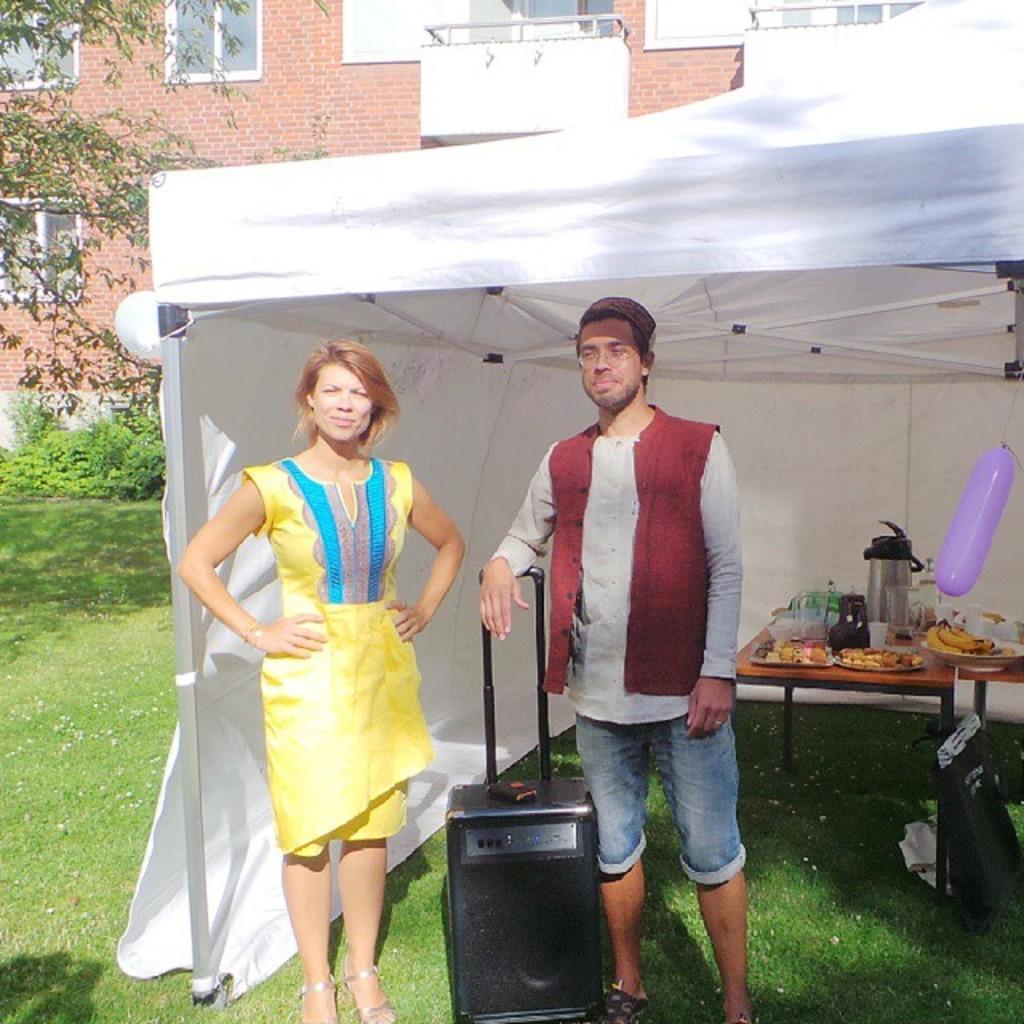Describe this image in one or two sentences. A couple are standing under a tent with a portable music system in between them and some eatables on a table behind. 